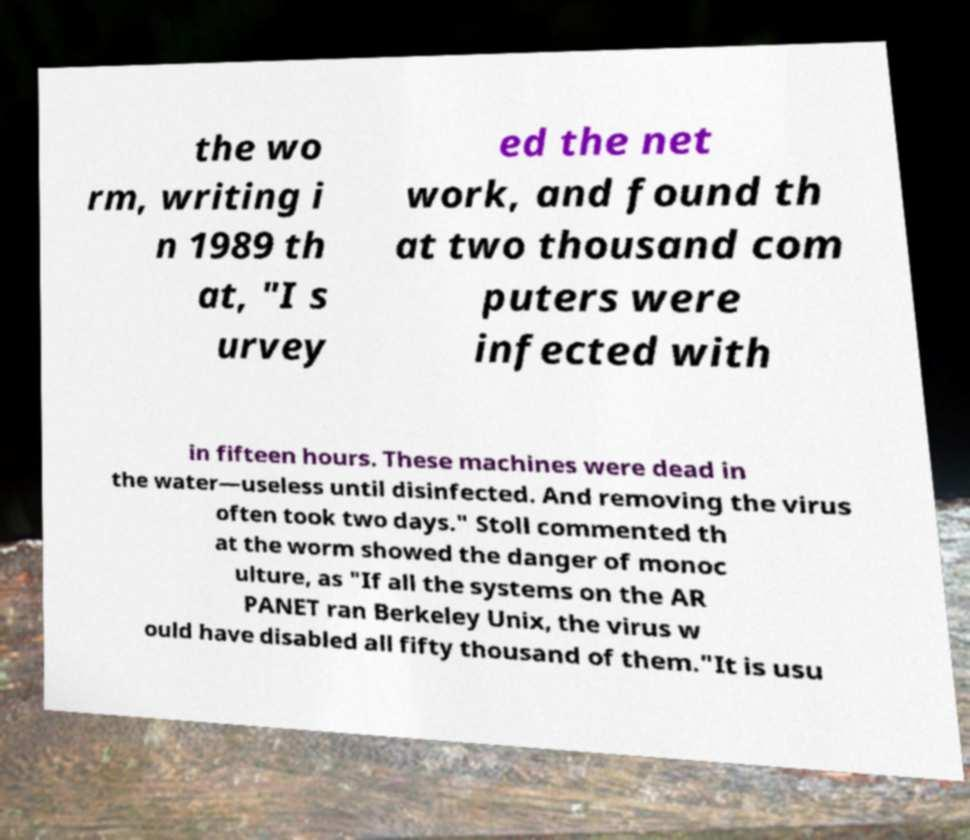Can you accurately transcribe the text from the provided image for me? the wo rm, writing i n 1989 th at, "I s urvey ed the net work, and found th at two thousand com puters were infected with in fifteen hours. These machines were dead in the water—useless until disinfected. And removing the virus often took two days." Stoll commented th at the worm showed the danger of monoc ulture, as "If all the systems on the AR PANET ran Berkeley Unix, the virus w ould have disabled all fifty thousand of them."It is usu 